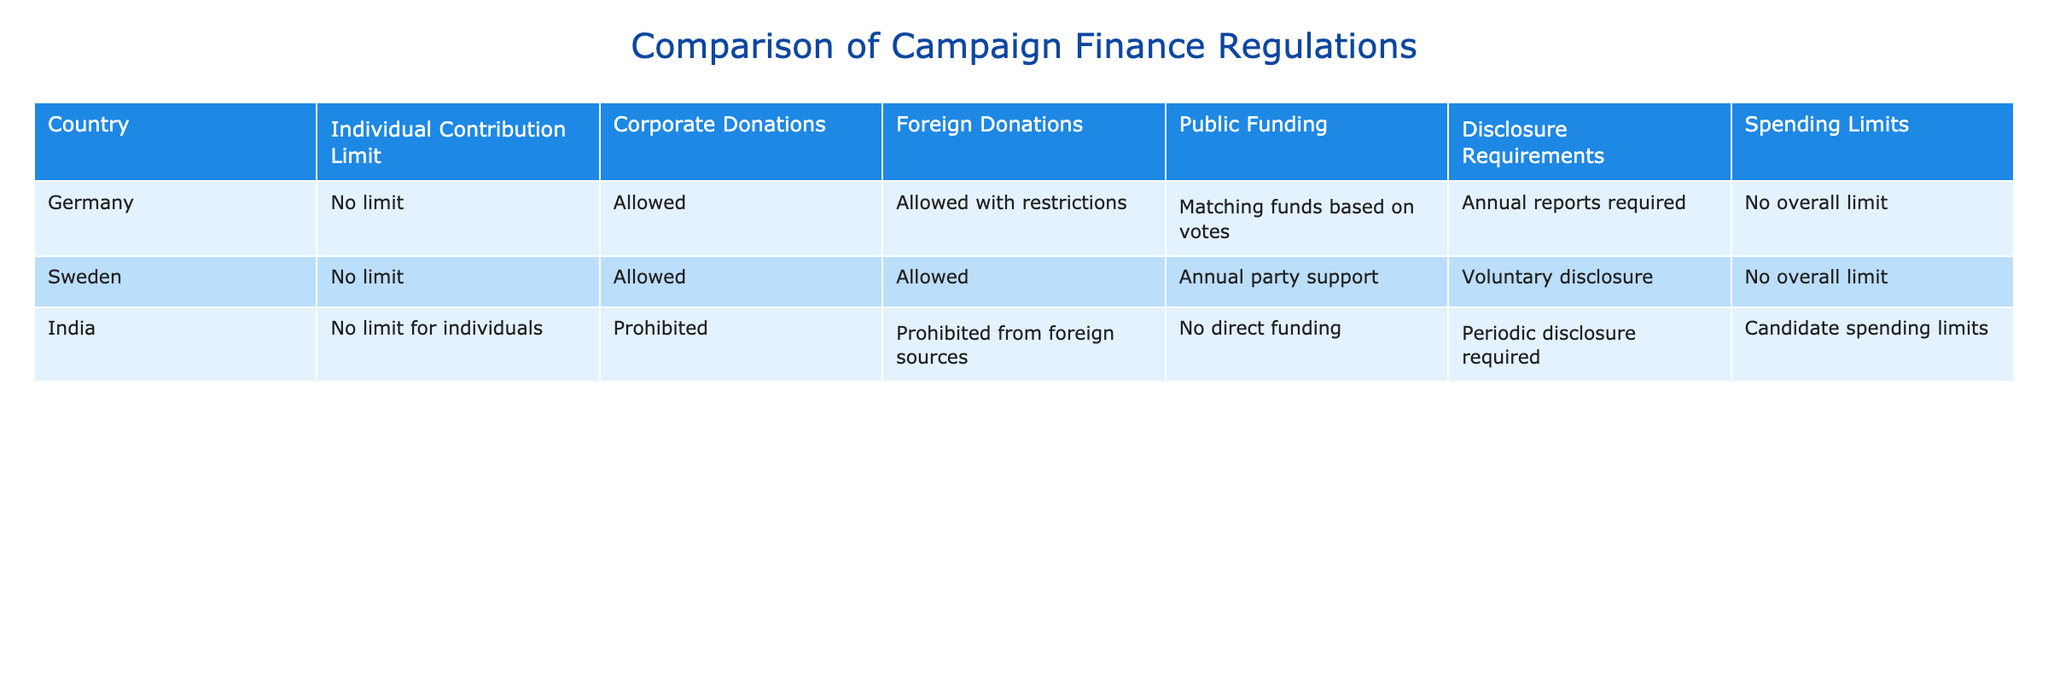What are the individual contribution limits in Germany, Sweden, and India? The table indicates that Germany and Sweden have no limit on individual contributions while India has no limit for individuals. Therefore, when summarizing, I find that the individual contribution limits for Germany and Sweden is "No limit" and for India, it also is "No limit for individuals."
Answer: No limit for Germany, No limit for Sweden, No limit for India Are corporate donations allowed in all three countries? In the table, Germany and Sweden both allow corporate donations, while India prohibits them. Thus, not all three countries allow corporate donations since India does not permit them.
Answer: No Does Sweden provide public funding for campaigns? According to the table, Sweden offers annual party support as public funding, making it clear that public funding is indeed available for campaigns in Sweden.
Answer: Yes What are the disclosure requirements for each country? The table shows that Germany requires annual reports, Sweden has voluntary disclosure, and India requires periodic disclosure. Hence, the disclosure requirements vary among them with distinct formats: annual reports, voluntary, and periodic.
Answer: Annual reports for Germany, Voluntary disclosure for Sweden, Periodic disclosure for India Which country has the most restrictions on foreign donations? The table reveals that Germany allows foreign donations with restrictions, Sweden allows them generally, but India prohibits foreign donations from foreign sources. Thus, India has the most restrictions on foreign donations as it completely prohibits them.
Answer: India What is the spending limit situation in India compared to Germany and Sweden? The table indicates that India has candidate spending limits, whereas both Germany and Sweden have no overall spending limits. In this comparison, India has specific limits, while the others have no caps.
Answer: India has limits; Germany and Sweden do not 